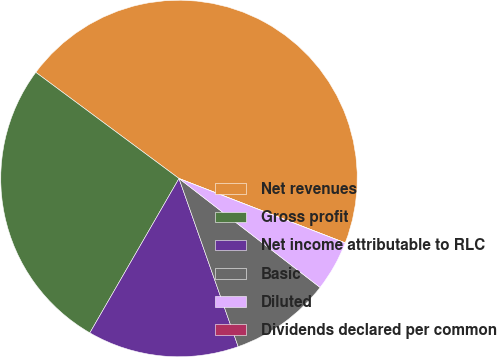Convert chart to OTSL. <chart><loc_0><loc_0><loc_500><loc_500><pie_chart><fcel>Net revenues<fcel>Gross profit<fcel>Net income attributable to RLC<fcel>Basic<fcel>Diluted<fcel>Dividends declared per common<nl><fcel>45.73%<fcel>26.82%<fcel>13.72%<fcel>9.15%<fcel>4.58%<fcel>0.0%<nl></chart> 